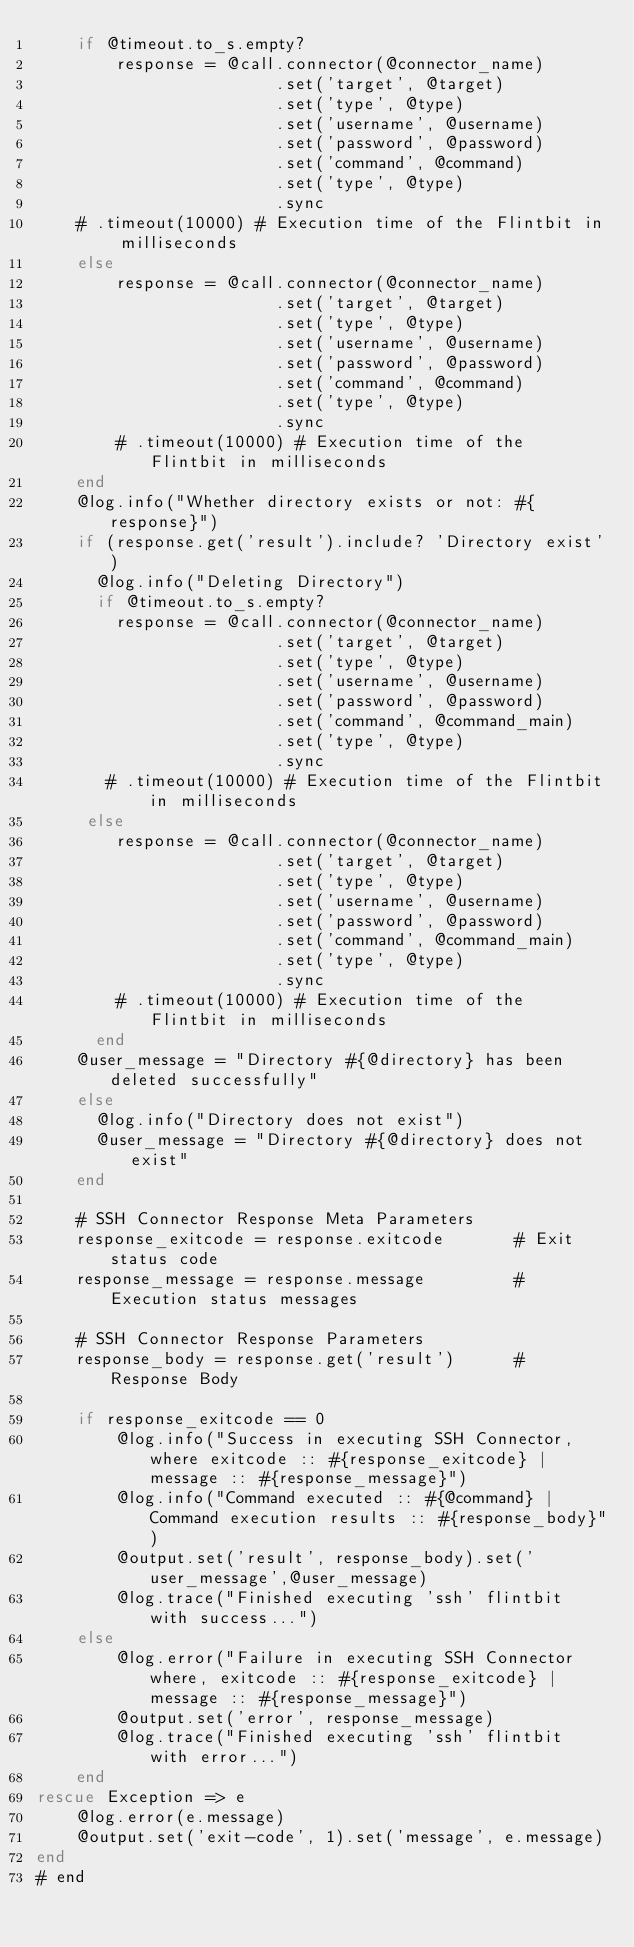<code> <loc_0><loc_0><loc_500><loc_500><_Ruby_>    if @timeout.to_s.empty?
        response = @call.connector(@connector_name)
                        .set('target', @target)
                        .set('type', @type)
                        .set('username', @username)
                        .set('password', @password)
                        .set('command', @command)
                        .set('type', @type)
                        .sync
    # .timeout(10000) # Execution time of the Flintbit in milliseconds
    else
        response = @call.connector(@connector_name)
                        .set('target', @target)
                        .set('type', @type)
                        .set('username', @username)
                        .set('password', @password)
                        .set('command', @command)
                        .set('type', @type)
                        .sync
        # .timeout(10000) # Execution time of the Flintbit in milliseconds
    end
    @log.info("Whether directory exists or not: #{response}")
    if (response.get('result').include? 'Directory exist')
      @log.info("Deleting Directory")
      if @timeout.to_s.empty?
        response = @call.connector(@connector_name)
                        .set('target', @target)
                        .set('type', @type)
                        .set('username', @username)
                        .set('password', @password)
                        .set('command', @command_main)
                        .set('type', @type)
                        .sync
       # .timeout(10000) # Execution time of the Flintbit in milliseconds
     else
        response = @call.connector(@connector_name)
                        .set('target', @target)
                        .set('type', @type)
                        .set('username', @username)
                        .set('password', @password)
                        .set('command', @command_main)
                        .set('type', @type)
                        .sync
        # .timeout(10000) # Execution time of the Flintbit in milliseconds
      end
    @user_message = "Directory #{@directory} has been deleted successfully"
    else
      @log.info("Directory does not exist")
      @user_message = "Directory #{@directory} does not exist"
    end

    # SSH Connector Response Meta Parameters
    response_exitcode = response.exitcode       # Exit status code
    response_message = response.message         # Execution status messages

    # SSH Connector Response Parameters
    response_body = response.get('result')      # Response Body

    if response_exitcode == 0
        @log.info("Success in executing SSH Connector, where exitcode :: #{response_exitcode} | message :: #{response_message}")
        @log.info("Command executed :: #{@command} | Command execution results :: #{response_body}")
        @output.set('result', response_body).set('user_message',@user_message)
        @log.trace("Finished executing 'ssh' flintbit with success...")
    else
        @log.error("Failure in executing SSH Connector where, exitcode :: #{response_exitcode} | message :: #{response_message}")
        @output.set('error', response_message)
        @log.trace("Finished executing 'ssh' flintbit with error...")
    end
rescue Exception => e
    @log.error(e.message)
    @output.set('exit-code', 1).set('message', e.message)
end
# end

</code> 